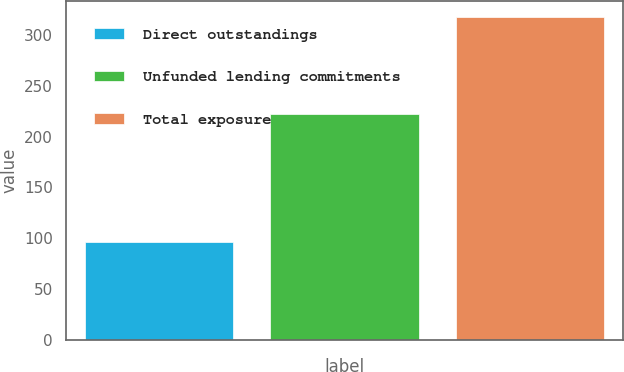<chart> <loc_0><loc_0><loc_500><loc_500><bar_chart><fcel>Direct outstandings<fcel>Unfunded lending commitments<fcel>Total exposure<nl><fcel>96<fcel>222<fcel>318<nl></chart> 